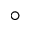Convert formula to latex. <formula><loc_0><loc_0><loc_500><loc_500>^ { \circ }</formula> 